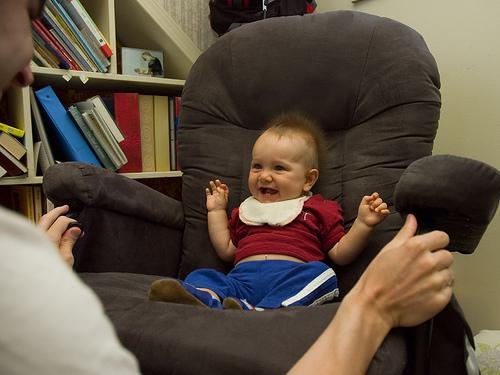Who else might be present in the room, based on what you can see? There appears to be at least one adult in the room, as evidenced by the hands coming into the frame from either side, likely belonging to a parent or caregiver playing with the baby. 